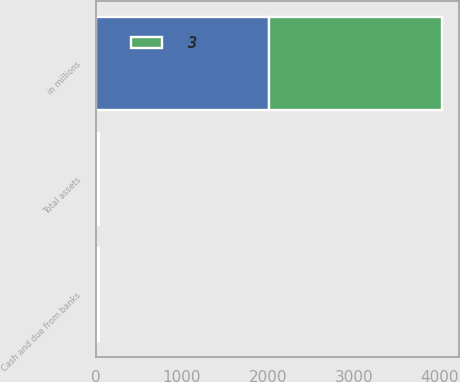Convert chart to OTSL. <chart><loc_0><loc_0><loc_500><loc_500><stacked_bar_chart><ecel><fcel>in millions<fcel>Cash and due from banks<fcel>Total assets<nl><fcel>nan<fcel>2015<fcel>15<fcel>15<nl><fcel>3<fcel>2014<fcel>19<fcel>19<nl></chart> 